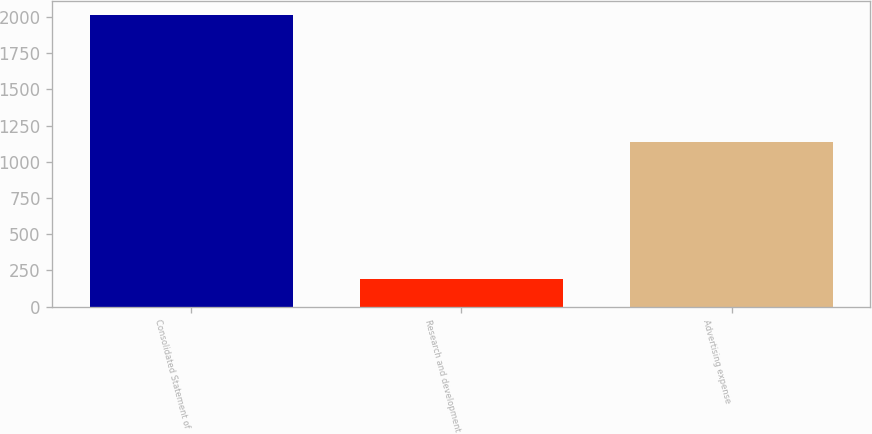<chart> <loc_0><loc_0><loc_500><loc_500><bar_chart><fcel>Consolidated Statement of<fcel>Research and development<fcel>Advertising expense<nl><fcel>2011<fcel>192<fcel>1138<nl></chart> 